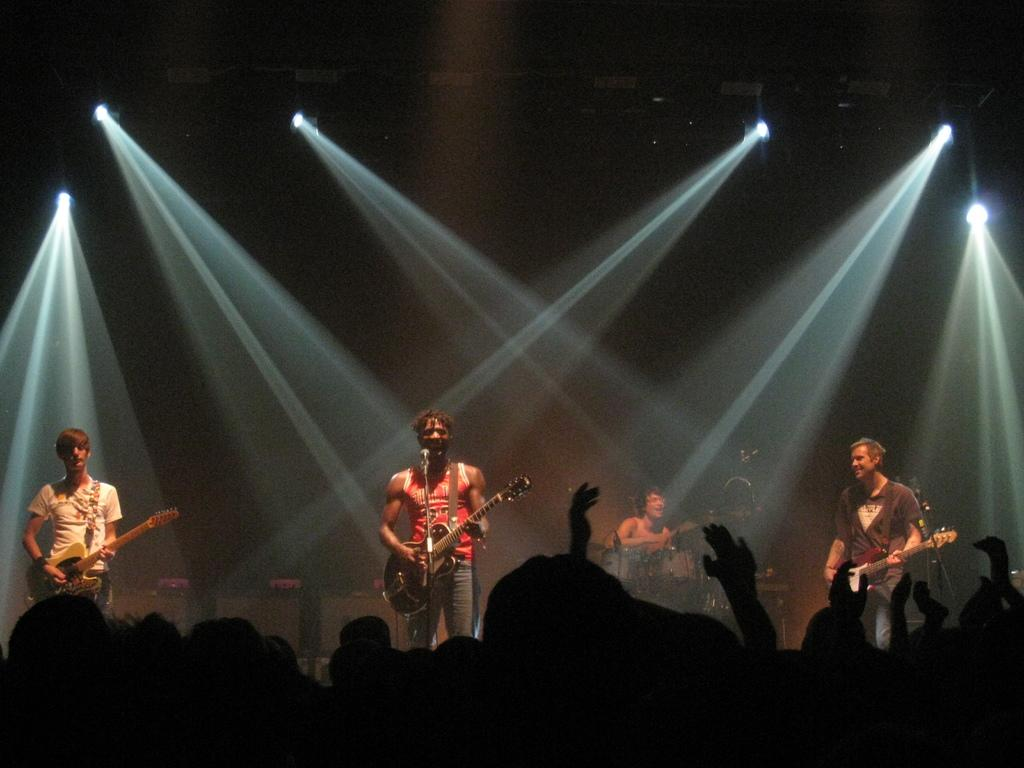What type of performance is taking place in the image? There is a rock band performing in the image. Where is the performance happening? The performance is taking place in a concert. What type of glue is being used by the rock band during the performance? There is no glue present or being used by the rock band during the performance in the image. Can you see any horses performing with the rock band in the image? No, there are no horses present or performing with the rock band in the image. 